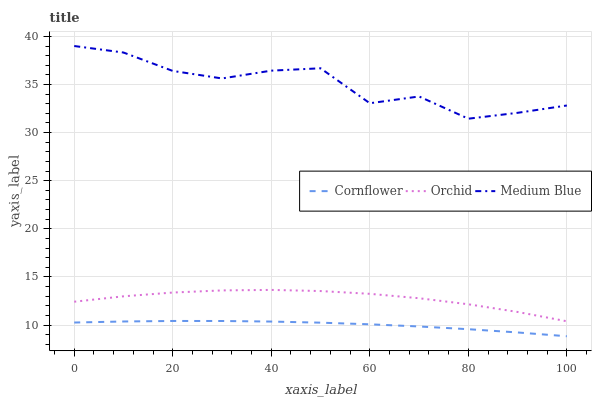Does Cornflower have the minimum area under the curve?
Answer yes or no. Yes. Does Medium Blue have the maximum area under the curve?
Answer yes or no. Yes. Does Orchid have the minimum area under the curve?
Answer yes or no. No. Does Orchid have the maximum area under the curve?
Answer yes or no. No. Is Cornflower the smoothest?
Answer yes or no. Yes. Is Medium Blue the roughest?
Answer yes or no. Yes. Is Orchid the smoothest?
Answer yes or no. No. Is Orchid the roughest?
Answer yes or no. No. Does Cornflower have the lowest value?
Answer yes or no. Yes. Does Orchid have the lowest value?
Answer yes or no. No. Does Medium Blue have the highest value?
Answer yes or no. Yes. Does Orchid have the highest value?
Answer yes or no. No. Is Cornflower less than Medium Blue?
Answer yes or no. Yes. Is Orchid greater than Cornflower?
Answer yes or no. Yes. Does Cornflower intersect Medium Blue?
Answer yes or no. No. 